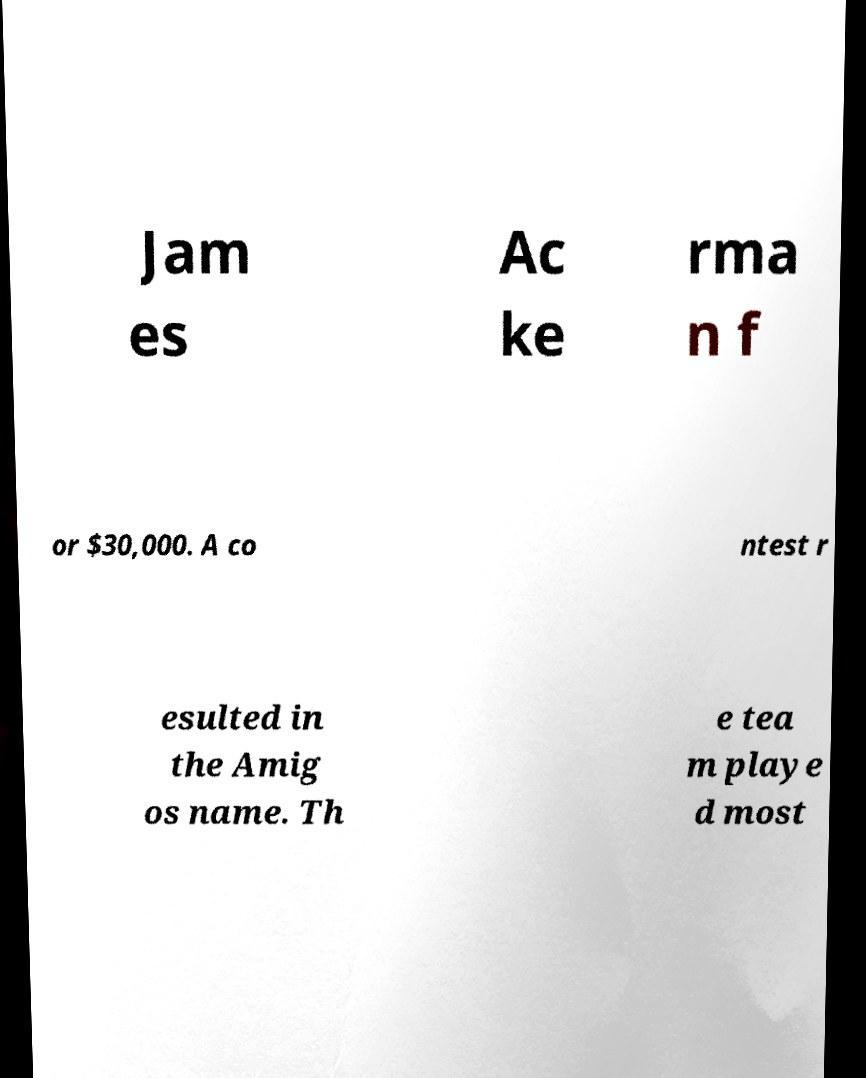Can you read and provide the text displayed in the image?This photo seems to have some interesting text. Can you extract and type it out for me? Jam es Ac ke rma n f or $30,000. A co ntest r esulted in the Amig os name. Th e tea m playe d most 